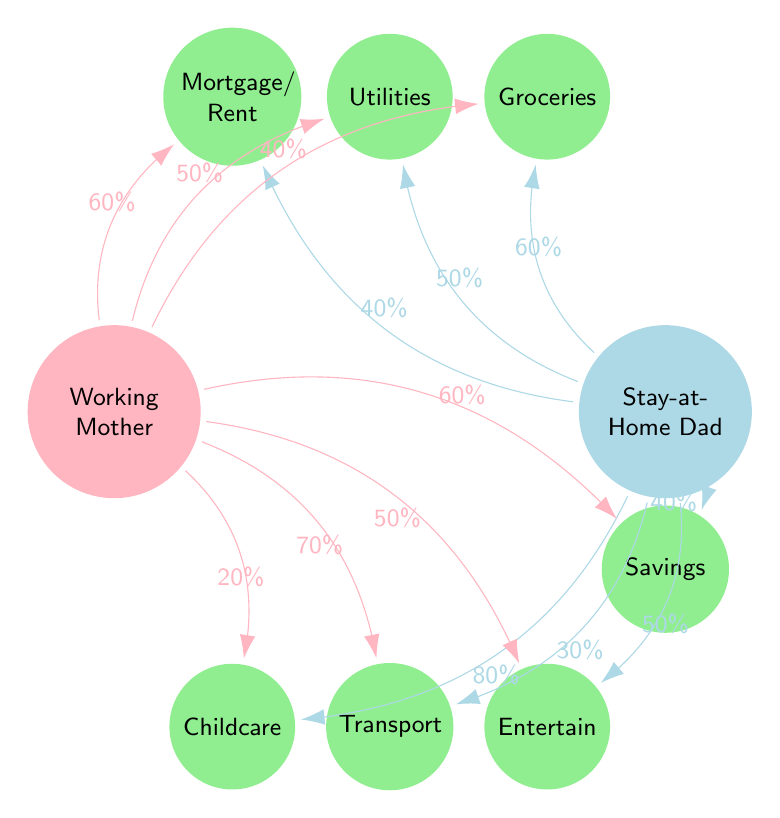What percentage does the Working Mother contribute to the Mortgage? The diagram shows a connection between the Working Mother and the Mortgage with a label indicating the contribution percentage as 60% from the Working Mother.
Answer: 60% What percentage does the Stay-at-Home Dad contribute to Childcare? The diagram indicates that the Stay-at-Home Dad contributes 80% to the Childcare expense, shown by the connecting line labeled with that percentage.
Answer: 80% How many expense categories are represented in the diagram? The diagram features six unique expense categories (Mortgage/Rent, Utilities, Groceries, Childcare, Transportation, Entertainment, and Savings), which can be counted from the expense nodes.
Answer: 7 Which expense category has the highest contribution from the Stay-at-Home Dad? Upon reviewing the contributions, Childcare has the highest percentage from the Stay-at-Home Dad at 80%, indicating it is the category he contributes to the most.
Answer: Childcare In how many expense categories do both parents contribute equally? By examining the contributions directly related to the Utilities and Entertainment categories, both parents equally contribute 50%, showing there are two categories with equal contributions.
Answer: 2 What is the total percentage contribution of the Working Mother across all expense categories? Adding the individual contributions from the Working Mother: 60% (Mortgage) + 50% (Utilities) + 40% (Groceries) + 20% (Childcare) + 70% (Transportation) + 50% (Entertainment) + 60% (Savings) results in a total of 350%.
Answer: 350% Which expense category has the lowest contribution from the Working Mother? Analyzing the contributions shows that the Working Mother contributes the least to Childcare at 20%, making it the lowest percentage she contributes across all categories.
Answer: Childcare What is the percentage contribution of the Stay-at-Home Dad for Savings? The diagram highlights a 40% contribution from the Stay-at-Home Dad to the Savings category, shown clearly by the connecting arrow and label.
Answer: 40% 